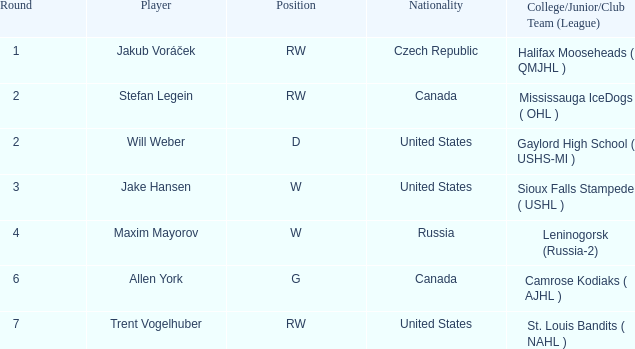What college or league did the round 2 pick with d position come from? Gaylord High School ( USHS-MI ). 